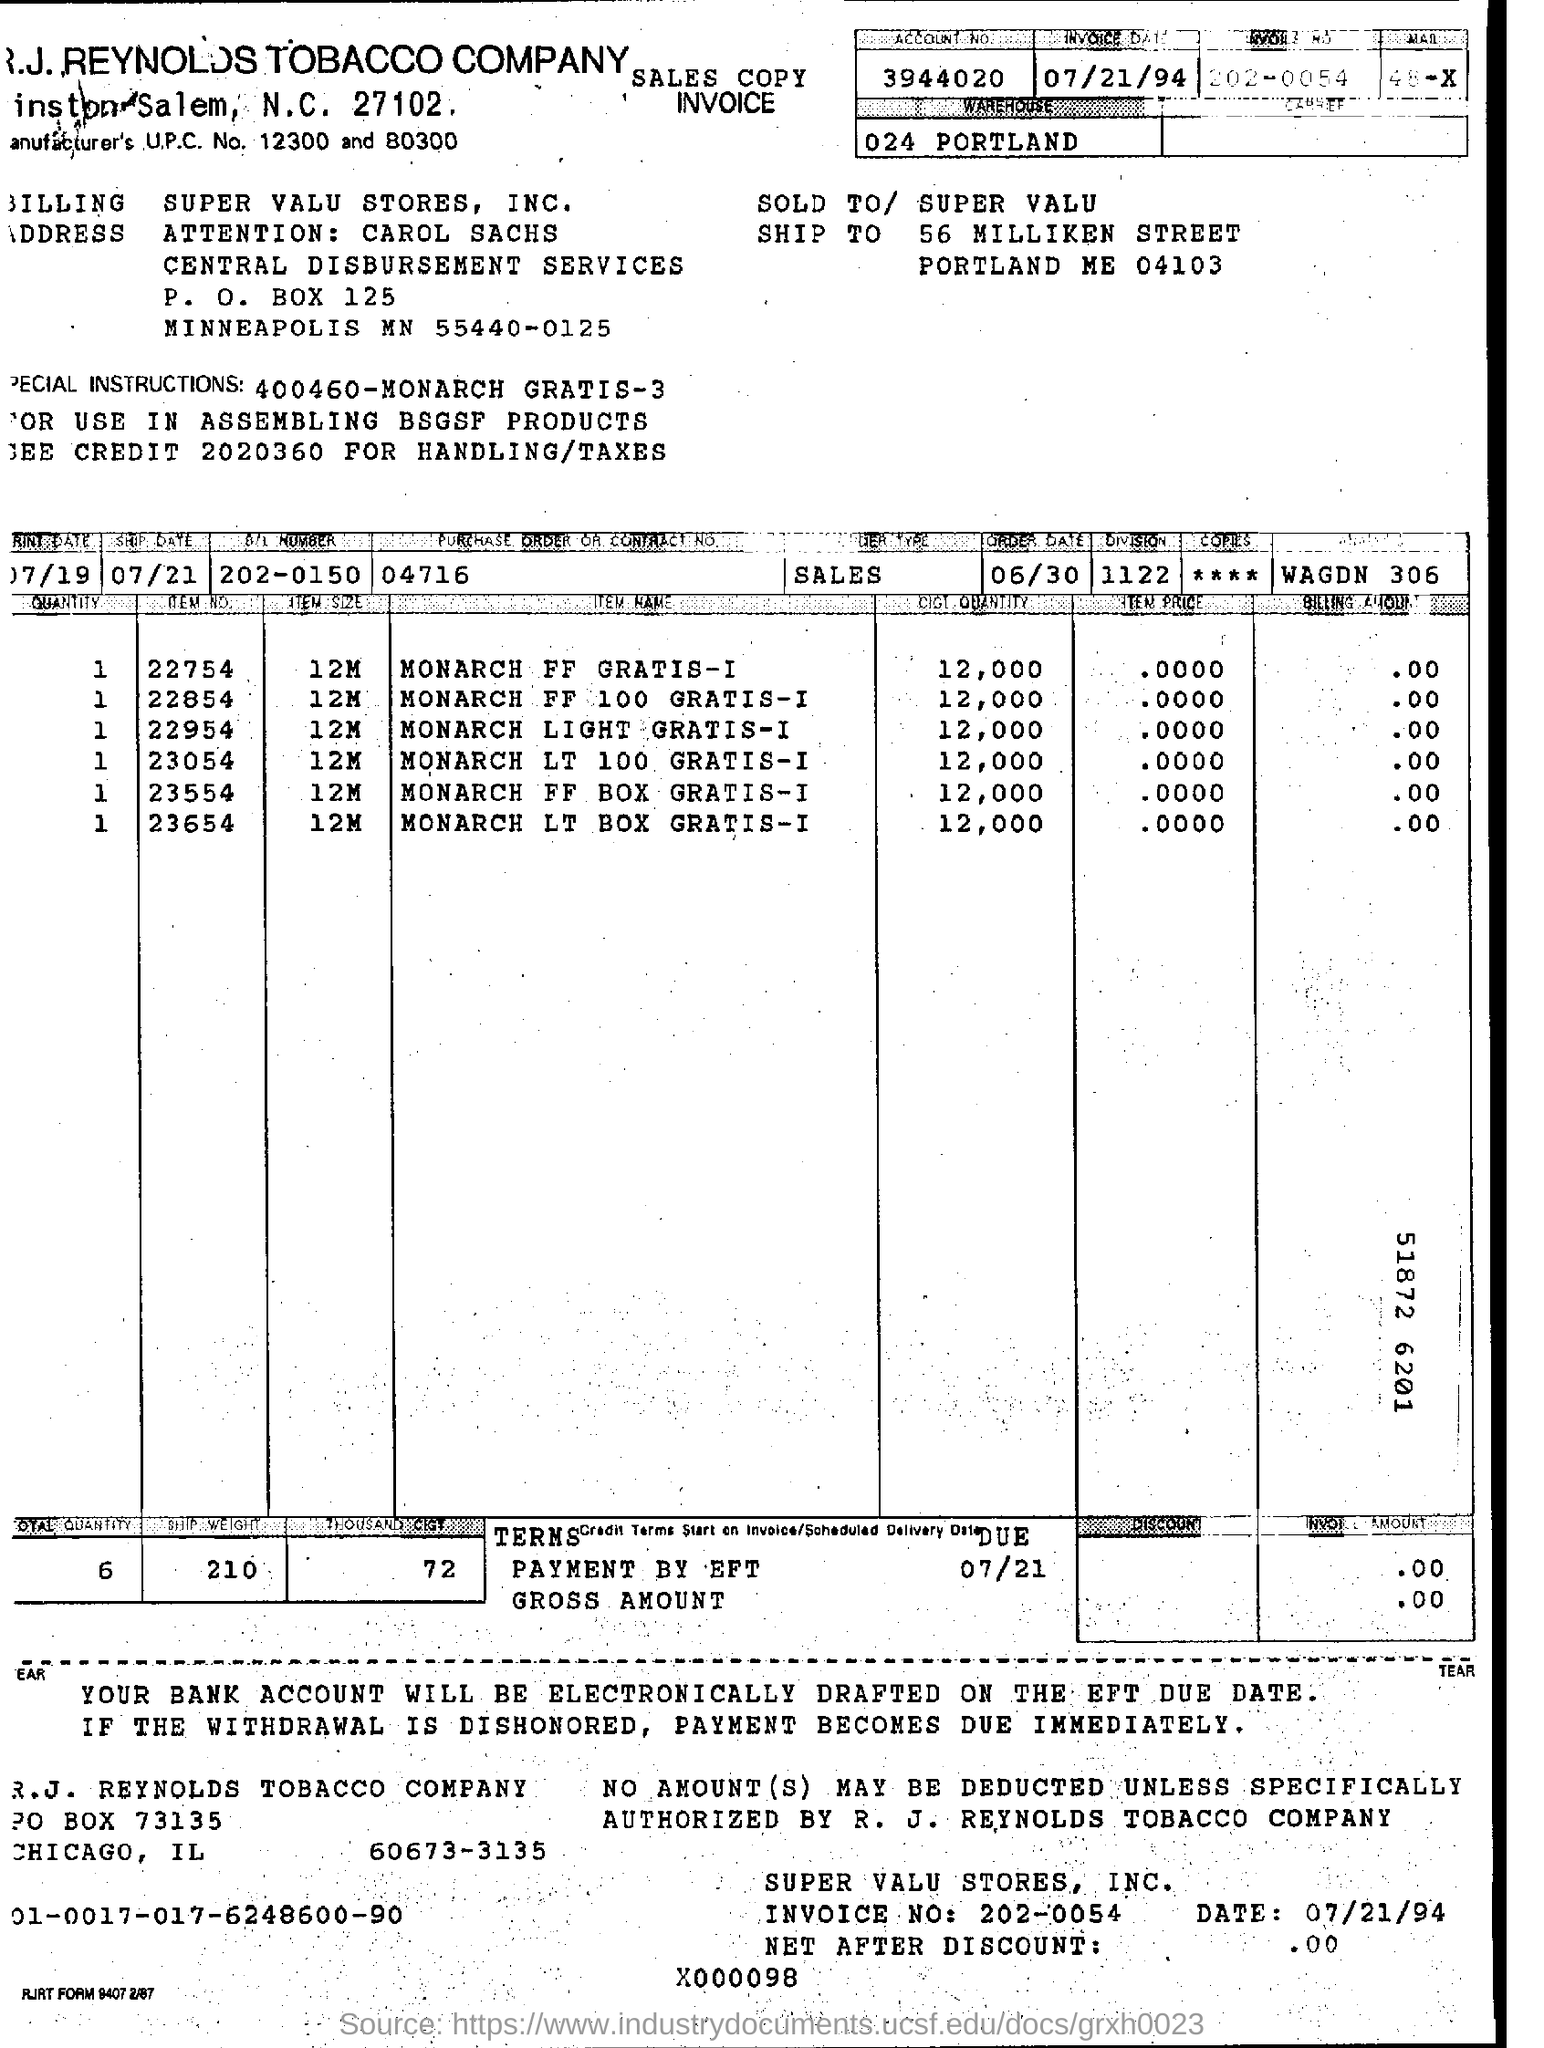Give some essential details in this illustration. The invoice date is July 21, 1994. 